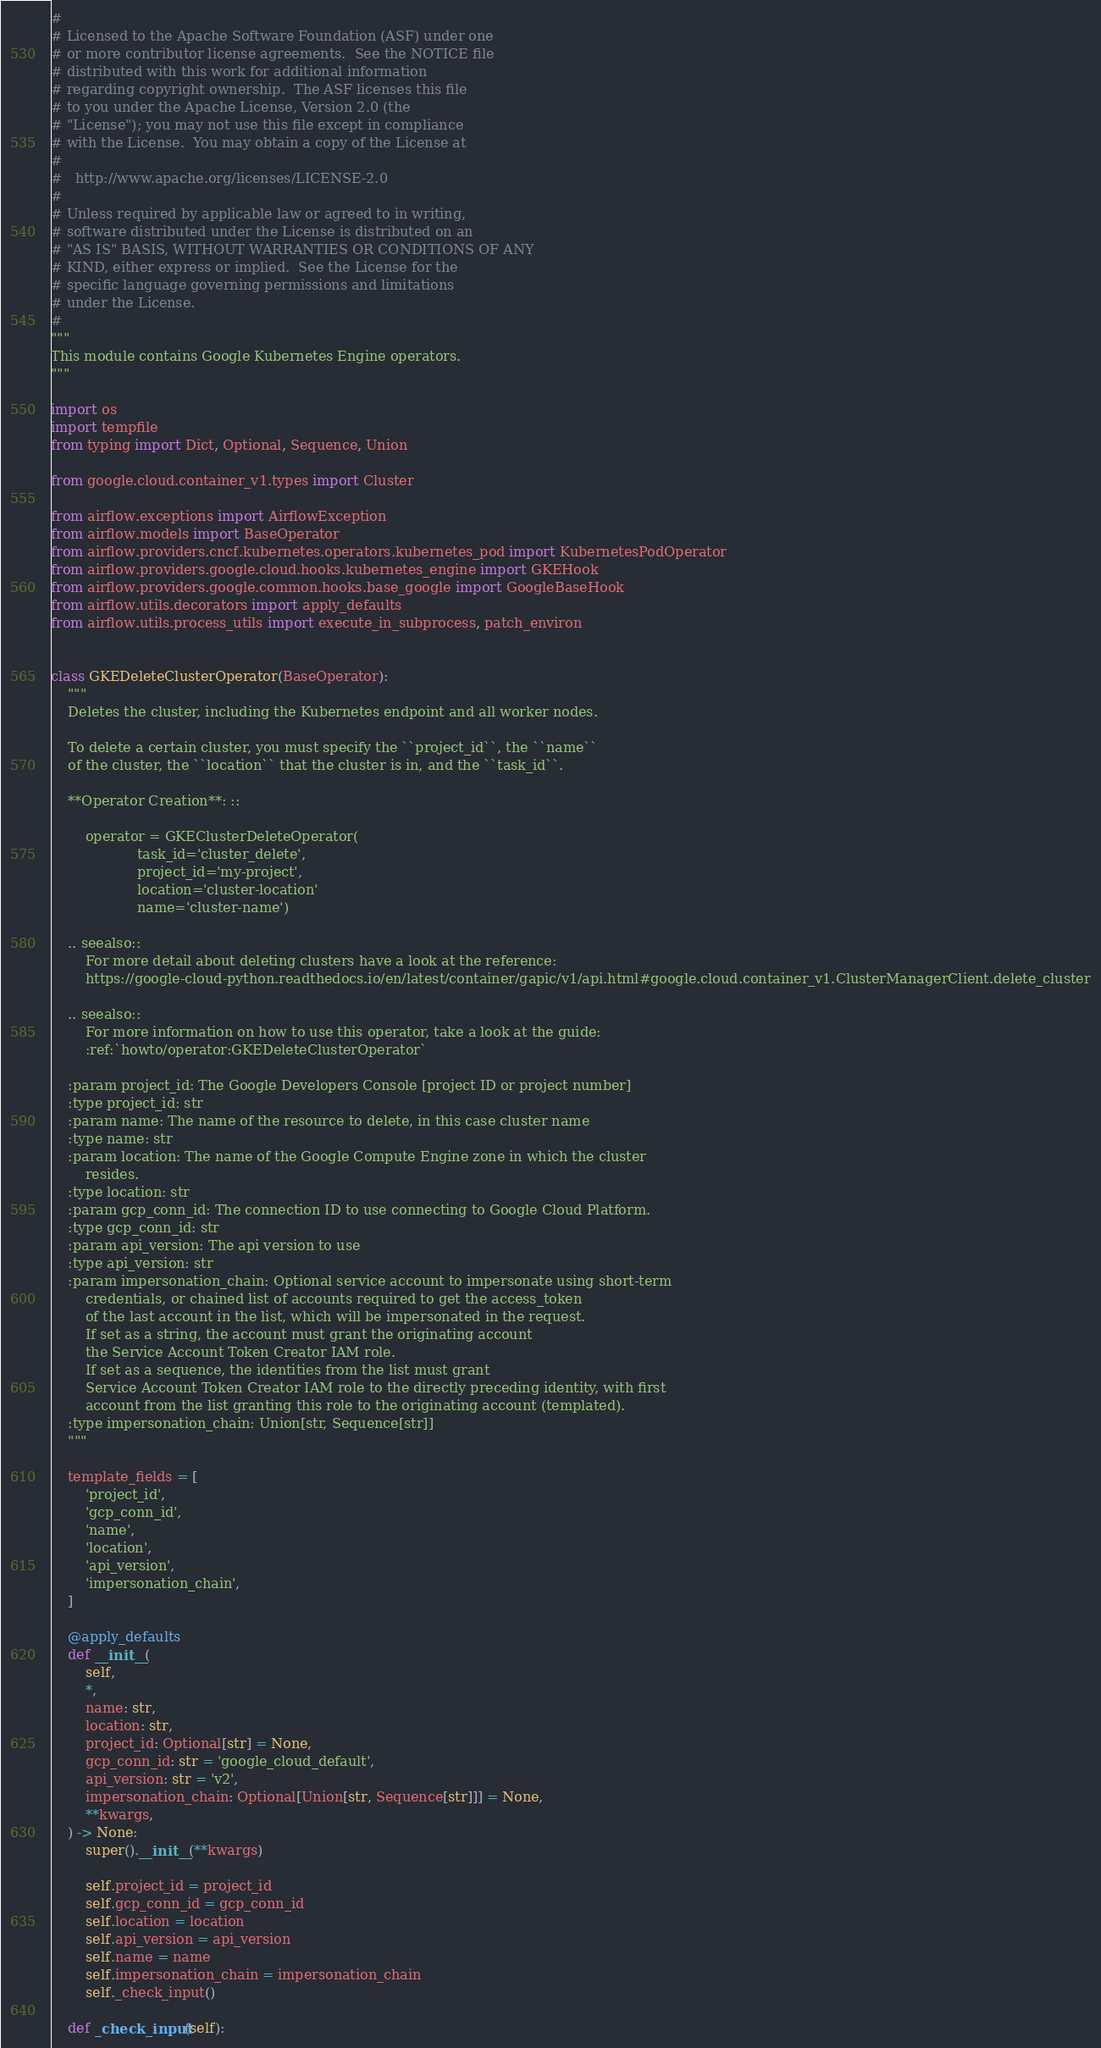<code> <loc_0><loc_0><loc_500><loc_500><_Python_>#
# Licensed to the Apache Software Foundation (ASF) under one
# or more contributor license agreements.  See the NOTICE file
# distributed with this work for additional information
# regarding copyright ownership.  The ASF licenses this file
# to you under the Apache License, Version 2.0 (the
# "License"); you may not use this file except in compliance
# with the License.  You may obtain a copy of the License at
#
#   http://www.apache.org/licenses/LICENSE-2.0
#
# Unless required by applicable law or agreed to in writing,
# software distributed under the License is distributed on an
# "AS IS" BASIS, WITHOUT WARRANTIES OR CONDITIONS OF ANY
# KIND, either express or implied.  See the License for the
# specific language governing permissions and limitations
# under the License.
#
"""
This module contains Google Kubernetes Engine operators.
"""

import os
import tempfile
from typing import Dict, Optional, Sequence, Union

from google.cloud.container_v1.types import Cluster

from airflow.exceptions import AirflowException
from airflow.models import BaseOperator
from airflow.providers.cncf.kubernetes.operators.kubernetes_pod import KubernetesPodOperator
from airflow.providers.google.cloud.hooks.kubernetes_engine import GKEHook
from airflow.providers.google.common.hooks.base_google import GoogleBaseHook
from airflow.utils.decorators import apply_defaults
from airflow.utils.process_utils import execute_in_subprocess, patch_environ


class GKEDeleteClusterOperator(BaseOperator):
    """
    Deletes the cluster, including the Kubernetes endpoint and all worker nodes.

    To delete a certain cluster, you must specify the ``project_id``, the ``name``
    of the cluster, the ``location`` that the cluster is in, and the ``task_id``.

    **Operator Creation**: ::

        operator = GKEClusterDeleteOperator(
                    task_id='cluster_delete',
                    project_id='my-project',
                    location='cluster-location'
                    name='cluster-name')

    .. seealso::
        For more detail about deleting clusters have a look at the reference:
        https://google-cloud-python.readthedocs.io/en/latest/container/gapic/v1/api.html#google.cloud.container_v1.ClusterManagerClient.delete_cluster

    .. seealso::
        For more information on how to use this operator, take a look at the guide:
        :ref:`howto/operator:GKEDeleteClusterOperator`

    :param project_id: The Google Developers Console [project ID or project number]
    :type project_id: str
    :param name: The name of the resource to delete, in this case cluster name
    :type name: str
    :param location: The name of the Google Compute Engine zone in which the cluster
        resides.
    :type location: str
    :param gcp_conn_id: The connection ID to use connecting to Google Cloud Platform.
    :type gcp_conn_id: str
    :param api_version: The api version to use
    :type api_version: str
    :param impersonation_chain: Optional service account to impersonate using short-term
        credentials, or chained list of accounts required to get the access_token
        of the last account in the list, which will be impersonated in the request.
        If set as a string, the account must grant the originating account
        the Service Account Token Creator IAM role.
        If set as a sequence, the identities from the list must grant
        Service Account Token Creator IAM role to the directly preceding identity, with first
        account from the list granting this role to the originating account (templated).
    :type impersonation_chain: Union[str, Sequence[str]]
    """

    template_fields = [
        'project_id',
        'gcp_conn_id',
        'name',
        'location',
        'api_version',
        'impersonation_chain',
    ]

    @apply_defaults
    def __init__(
        self,
        *,
        name: str,
        location: str,
        project_id: Optional[str] = None,
        gcp_conn_id: str = 'google_cloud_default',
        api_version: str = 'v2',
        impersonation_chain: Optional[Union[str, Sequence[str]]] = None,
        **kwargs,
    ) -> None:
        super().__init__(**kwargs)

        self.project_id = project_id
        self.gcp_conn_id = gcp_conn_id
        self.location = location
        self.api_version = api_version
        self.name = name
        self.impersonation_chain = impersonation_chain
        self._check_input()

    def _check_input(self):</code> 